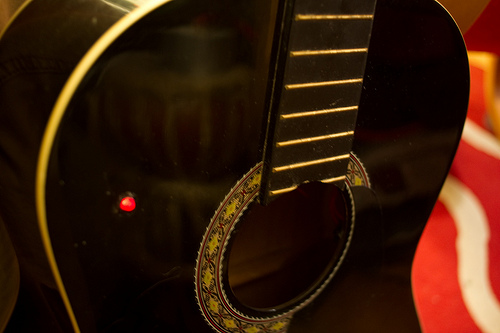<image>
Is there a light on the guitar? Yes. Looking at the image, I can see the light is positioned on top of the guitar, with the guitar providing support. 